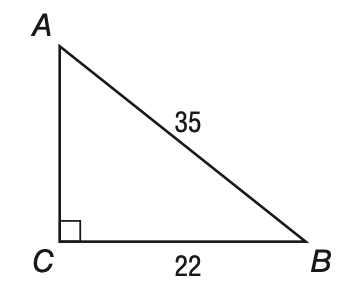Answer the mathemtical geometry problem and directly provide the correct option letter.
Question: In right triangle A B C shown below, what is the measure of \angle A to the nearest tenth of a degree?
Choices: A: 32.2 B: 38.9 C: 51.1 D: 57.8 B 